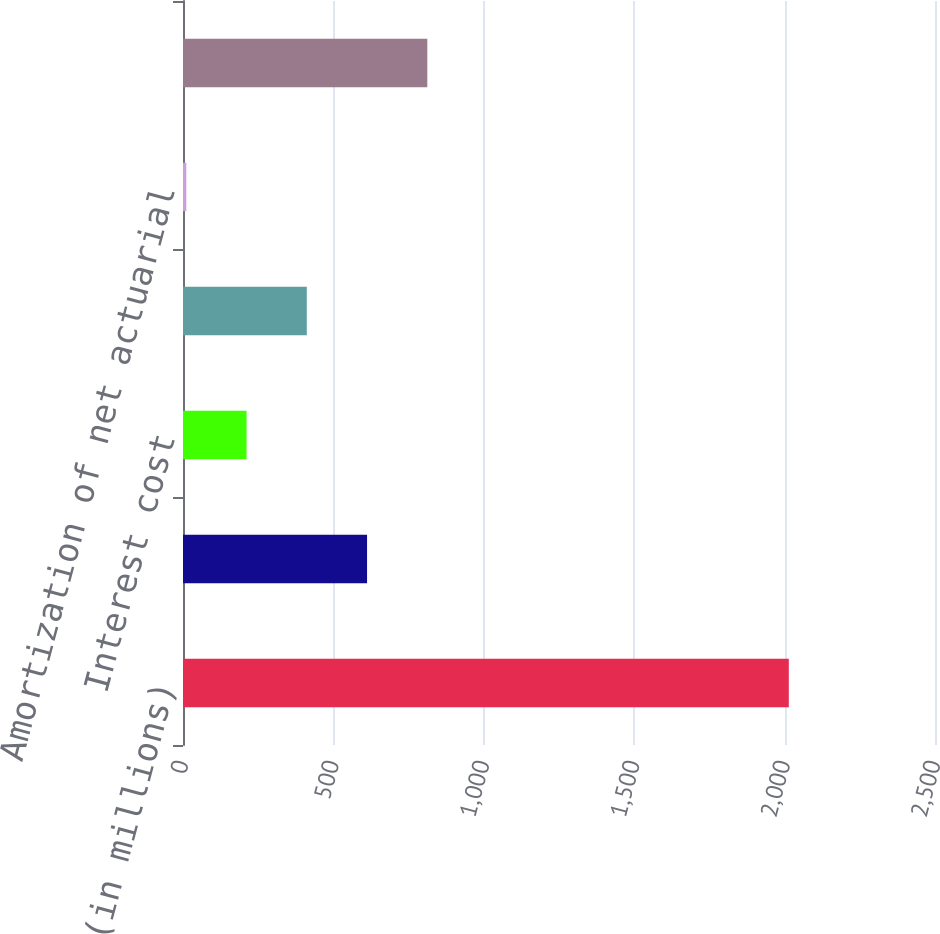<chart> <loc_0><loc_0><loc_500><loc_500><bar_chart><fcel>(in millions)<fcel>Service cost<fcel>Interest cost<fcel>Expected return on plan assets<fcel>Amortization of net actuarial<fcel>Net periodic benefit cost<nl><fcel>2014<fcel>611.9<fcel>211.3<fcel>411.6<fcel>11<fcel>812.2<nl></chart> 